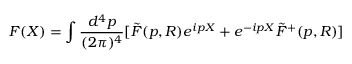Convert formula to latex. <formula><loc_0><loc_0><loc_500><loc_500>F ( X ) = \int \frac { d ^ { 4 } p } { ( 2 { \pi } ) ^ { 4 } } [ \tilde { F } ( p , R ) e ^ { i p X } + e ^ { - i p X } \tilde { F } ^ { + } ( p , R ) ]</formula> 